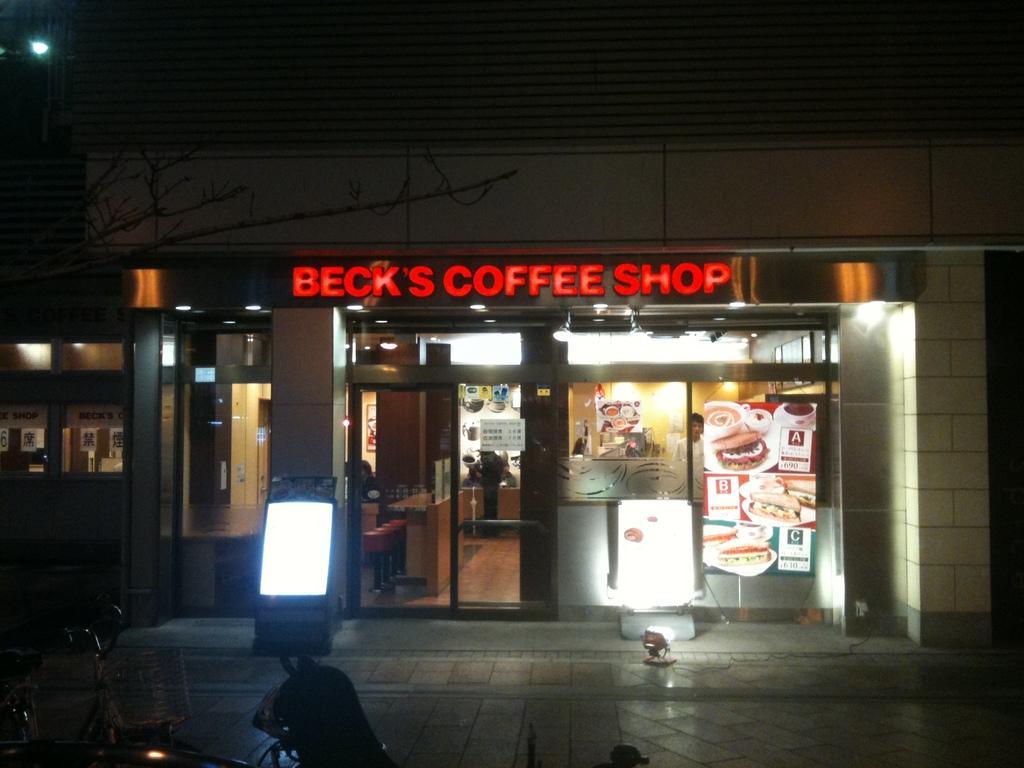Can you describe this image briefly? In this picture we can see a bicycle and a light on the path. We can see a text written on a board. There is a coffee shop. In this shop, we can see a few people and some lights on top. There are few things visible in the coffee shop. 